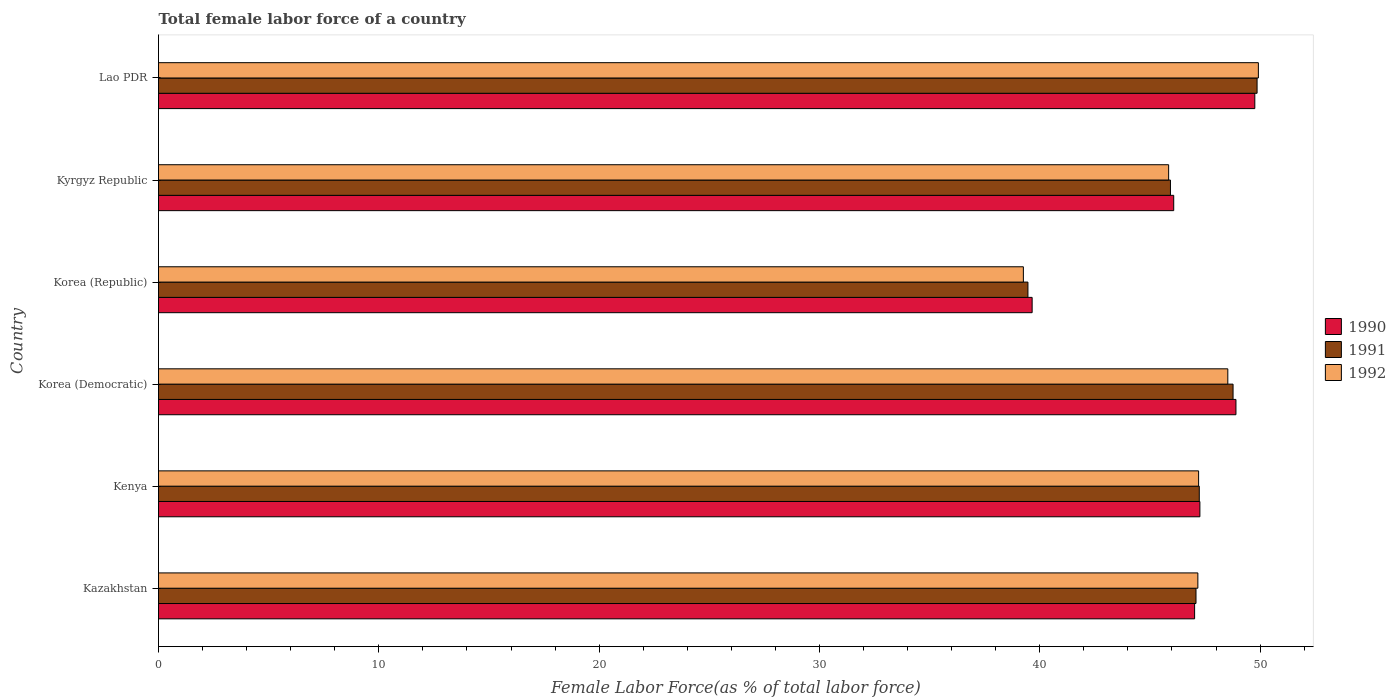How many different coloured bars are there?
Keep it short and to the point. 3. How many groups of bars are there?
Offer a very short reply. 6. How many bars are there on the 2nd tick from the top?
Offer a very short reply. 3. What is the label of the 6th group of bars from the top?
Make the answer very short. Kazakhstan. What is the percentage of female labor force in 1991 in Korea (Democratic)?
Your response must be concise. 48.77. Across all countries, what is the maximum percentage of female labor force in 1992?
Make the answer very short. 49.92. Across all countries, what is the minimum percentage of female labor force in 1991?
Offer a very short reply. 39.46. In which country was the percentage of female labor force in 1991 maximum?
Ensure brevity in your answer.  Lao PDR. What is the total percentage of female labor force in 1991 in the graph?
Provide a succinct answer. 278.37. What is the difference between the percentage of female labor force in 1990 in Kenya and that in Korea (Republic)?
Your answer should be compact. 7.61. What is the difference between the percentage of female labor force in 1992 in Korea (Democratic) and the percentage of female labor force in 1990 in Kazakhstan?
Ensure brevity in your answer.  1.51. What is the average percentage of female labor force in 1992 per country?
Make the answer very short. 46.33. What is the difference between the percentage of female labor force in 1991 and percentage of female labor force in 1990 in Korea (Republic)?
Keep it short and to the point. -0.19. In how many countries, is the percentage of female labor force in 1990 greater than 44 %?
Provide a succinct answer. 5. What is the ratio of the percentage of female labor force in 1992 in Korea (Democratic) to that in Kyrgyz Republic?
Your answer should be compact. 1.06. Is the difference between the percentage of female labor force in 1991 in Kyrgyz Republic and Lao PDR greater than the difference between the percentage of female labor force in 1990 in Kyrgyz Republic and Lao PDR?
Ensure brevity in your answer.  No. What is the difference between the highest and the second highest percentage of female labor force in 1991?
Make the answer very short. 1.09. What is the difference between the highest and the lowest percentage of female labor force in 1990?
Offer a very short reply. 10.11. Is the sum of the percentage of female labor force in 1992 in Kenya and Korea (Republic) greater than the maximum percentage of female labor force in 1991 across all countries?
Offer a terse response. Yes. Where does the legend appear in the graph?
Give a very brief answer. Center right. How many legend labels are there?
Ensure brevity in your answer.  3. What is the title of the graph?
Keep it short and to the point. Total female labor force of a country. What is the label or title of the X-axis?
Your answer should be compact. Female Labor Force(as % of total labor force). What is the label or title of the Y-axis?
Make the answer very short. Country. What is the Female Labor Force(as % of total labor force) of 1990 in Kazakhstan?
Provide a succinct answer. 47.03. What is the Female Labor Force(as % of total labor force) of 1991 in Kazakhstan?
Make the answer very short. 47.09. What is the Female Labor Force(as % of total labor force) in 1992 in Kazakhstan?
Your response must be concise. 47.18. What is the Female Labor Force(as % of total labor force) in 1990 in Kenya?
Offer a terse response. 47.27. What is the Female Labor Force(as % of total labor force) of 1991 in Kenya?
Offer a very short reply. 47.24. What is the Female Labor Force(as % of total labor force) of 1992 in Kenya?
Offer a very short reply. 47.21. What is the Female Labor Force(as % of total labor force) in 1990 in Korea (Democratic)?
Provide a succinct answer. 48.91. What is the Female Labor Force(as % of total labor force) of 1991 in Korea (Democratic)?
Offer a very short reply. 48.77. What is the Female Labor Force(as % of total labor force) in 1992 in Korea (Democratic)?
Your answer should be very brief. 48.54. What is the Female Labor Force(as % of total labor force) of 1990 in Korea (Republic)?
Provide a succinct answer. 39.65. What is the Female Labor Force(as % of total labor force) of 1991 in Korea (Republic)?
Offer a terse response. 39.46. What is the Female Labor Force(as % of total labor force) of 1992 in Korea (Republic)?
Provide a succinct answer. 39.26. What is the Female Labor Force(as % of total labor force) in 1990 in Kyrgyz Republic?
Provide a short and direct response. 46.08. What is the Female Labor Force(as % of total labor force) in 1991 in Kyrgyz Republic?
Offer a very short reply. 45.93. What is the Female Labor Force(as % of total labor force) in 1992 in Kyrgyz Republic?
Keep it short and to the point. 45.85. What is the Female Labor Force(as % of total labor force) in 1990 in Lao PDR?
Provide a succinct answer. 49.76. What is the Female Labor Force(as % of total labor force) in 1991 in Lao PDR?
Your response must be concise. 49.86. What is the Female Labor Force(as % of total labor force) in 1992 in Lao PDR?
Your answer should be very brief. 49.92. Across all countries, what is the maximum Female Labor Force(as % of total labor force) of 1990?
Provide a short and direct response. 49.76. Across all countries, what is the maximum Female Labor Force(as % of total labor force) in 1991?
Provide a succinct answer. 49.86. Across all countries, what is the maximum Female Labor Force(as % of total labor force) in 1992?
Ensure brevity in your answer.  49.92. Across all countries, what is the minimum Female Labor Force(as % of total labor force) of 1990?
Your answer should be very brief. 39.65. Across all countries, what is the minimum Female Labor Force(as % of total labor force) of 1991?
Your answer should be compact. 39.46. Across all countries, what is the minimum Female Labor Force(as % of total labor force) of 1992?
Give a very brief answer. 39.26. What is the total Female Labor Force(as % of total labor force) in 1990 in the graph?
Keep it short and to the point. 278.7. What is the total Female Labor Force(as % of total labor force) of 1991 in the graph?
Your answer should be very brief. 278.37. What is the total Female Labor Force(as % of total labor force) of 1992 in the graph?
Give a very brief answer. 277.95. What is the difference between the Female Labor Force(as % of total labor force) in 1990 in Kazakhstan and that in Kenya?
Your answer should be very brief. -0.24. What is the difference between the Female Labor Force(as % of total labor force) of 1991 in Kazakhstan and that in Kenya?
Make the answer very short. -0.15. What is the difference between the Female Labor Force(as % of total labor force) of 1992 in Kazakhstan and that in Kenya?
Offer a terse response. -0.03. What is the difference between the Female Labor Force(as % of total labor force) of 1990 in Kazakhstan and that in Korea (Democratic)?
Give a very brief answer. -1.88. What is the difference between the Female Labor Force(as % of total labor force) of 1991 in Kazakhstan and that in Korea (Democratic)?
Ensure brevity in your answer.  -1.68. What is the difference between the Female Labor Force(as % of total labor force) of 1992 in Kazakhstan and that in Korea (Democratic)?
Ensure brevity in your answer.  -1.36. What is the difference between the Female Labor Force(as % of total labor force) in 1990 in Kazakhstan and that in Korea (Republic)?
Give a very brief answer. 7.37. What is the difference between the Female Labor Force(as % of total labor force) in 1991 in Kazakhstan and that in Korea (Republic)?
Offer a terse response. 7.63. What is the difference between the Female Labor Force(as % of total labor force) of 1992 in Kazakhstan and that in Korea (Republic)?
Keep it short and to the point. 7.92. What is the difference between the Female Labor Force(as % of total labor force) in 1990 in Kazakhstan and that in Kyrgyz Republic?
Your response must be concise. 0.95. What is the difference between the Female Labor Force(as % of total labor force) in 1991 in Kazakhstan and that in Kyrgyz Republic?
Give a very brief answer. 1.16. What is the difference between the Female Labor Force(as % of total labor force) in 1992 in Kazakhstan and that in Kyrgyz Republic?
Your answer should be compact. 1.33. What is the difference between the Female Labor Force(as % of total labor force) in 1990 in Kazakhstan and that in Lao PDR?
Your response must be concise. -2.73. What is the difference between the Female Labor Force(as % of total labor force) of 1991 in Kazakhstan and that in Lao PDR?
Provide a succinct answer. -2.77. What is the difference between the Female Labor Force(as % of total labor force) in 1992 in Kazakhstan and that in Lao PDR?
Give a very brief answer. -2.75. What is the difference between the Female Labor Force(as % of total labor force) of 1990 in Kenya and that in Korea (Democratic)?
Provide a short and direct response. -1.64. What is the difference between the Female Labor Force(as % of total labor force) in 1991 in Kenya and that in Korea (Democratic)?
Make the answer very short. -1.53. What is the difference between the Female Labor Force(as % of total labor force) of 1992 in Kenya and that in Korea (Democratic)?
Provide a succinct answer. -1.33. What is the difference between the Female Labor Force(as % of total labor force) of 1990 in Kenya and that in Korea (Republic)?
Provide a succinct answer. 7.61. What is the difference between the Female Labor Force(as % of total labor force) in 1991 in Kenya and that in Korea (Republic)?
Keep it short and to the point. 7.78. What is the difference between the Female Labor Force(as % of total labor force) in 1992 in Kenya and that in Korea (Republic)?
Offer a terse response. 7.95. What is the difference between the Female Labor Force(as % of total labor force) of 1990 in Kenya and that in Kyrgyz Republic?
Offer a terse response. 1.19. What is the difference between the Female Labor Force(as % of total labor force) of 1991 in Kenya and that in Kyrgyz Republic?
Your answer should be compact. 1.31. What is the difference between the Female Labor Force(as % of total labor force) of 1992 in Kenya and that in Kyrgyz Republic?
Your answer should be very brief. 1.36. What is the difference between the Female Labor Force(as % of total labor force) of 1990 in Kenya and that in Lao PDR?
Provide a short and direct response. -2.49. What is the difference between the Female Labor Force(as % of total labor force) in 1991 in Kenya and that in Lao PDR?
Offer a very short reply. -2.62. What is the difference between the Female Labor Force(as % of total labor force) of 1992 in Kenya and that in Lao PDR?
Provide a succinct answer. -2.71. What is the difference between the Female Labor Force(as % of total labor force) in 1990 in Korea (Democratic) and that in Korea (Republic)?
Your answer should be compact. 9.25. What is the difference between the Female Labor Force(as % of total labor force) of 1991 in Korea (Democratic) and that in Korea (Republic)?
Provide a short and direct response. 9.31. What is the difference between the Female Labor Force(as % of total labor force) of 1992 in Korea (Democratic) and that in Korea (Republic)?
Keep it short and to the point. 9.28. What is the difference between the Female Labor Force(as % of total labor force) of 1990 in Korea (Democratic) and that in Kyrgyz Republic?
Provide a short and direct response. 2.82. What is the difference between the Female Labor Force(as % of total labor force) of 1991 in Korea (Democratic) and that in Kyrgyz Republic?
Offer a terse response. 2.84. What is the difference between the Female Labor Force(as % of total labor force) of 1992 in Korea (Democratic) and that in Kyrgyz Republic?
Your response must be concise. 2.69. What is the difference between the Female Labor Force(as % of total labor force) in 1990 in Korea (Democratic) and that in Lao PDR?
Provide a succinct answer. -0.86. What is the difference between the Female Labor Force(as % of total labor force) in 1991 in Korea (Democratic) and that in Lao PDR?
Your response must be concise. -1.09. What is the difference between the Female Labor Force(as % of total labor force) in 1992 in Korea (Democratic) and that in Lao PDR?
Provide a succinct answer. -1.39. What is the difference between the Female Labor Force(as % of total labor force) of 1990 in Korea (Republic) and that in Kyrgyz Republic?
Provide a short and direct response. -6.43. What is the difference between the Female Labor Force(as % of total labor force) in 1991 in Korea (Republic) and that in Kyrgyz Republic?
Keep it short and to the point. -6.47. What is the difference between the Female Labor Force(as % of total labor force) of 1992 in Korea (Republic) and that in Kyrgyz Republic?
Your answer should be compact. -6.59. What is the difference between the Female Labor Force(as % of total labor force) in 1990 in Korea (Republic) and that in Lao PDR?
Give a very brief answer. -10.11. What is the difference between the Female Labor Force(as % of total labor force) in 1991 in Korea (Republic) and that in Lao PDR?
Your response must be concise. -10.4. What is the difference between the Female Labor Force(as % of total labor force) in 1992 in Korea (Republic) and that in Lao PDR?
Give a very brief answer. -10.67. What is the difference between the Female Labor Force(as % of total labor force) in 1990 in Kyrgyz Republic and that in Lao PDR?
Give a very brief answer. -3.68. What is the difference between the Female Labor Force(as % of total labor force) of 1991 in Kyrgyz Republic and that in Lao PDR?
Give a very brief answer. -3.93. What is the difference between the Female Labor Force(as % of total labor force) in 1992 in Kyrgyz Republic and that in Lao PDR?
Offer a terse response. -4.07. What is the difference between the Female Labor Force(as % of total labor force) of 1990 in Kazakhstan and the Female Labor Force(as % of total labor force) of 1991 in Kenya?
Ensure brevity in your answer.  -0.21. What is the difference between the Female Labor Force(as % of total labor force) of 1990 in Kazakhstan and the Female Labor Force(as % of total labor force) of 1992 in Kenya?
Offer a very short reply. -0.18. What is the difference between the Female Labor Force(as % of total labor force) of 1991 in Kazakhstan and the Female Labor Force(as % of total labor force) of 1992 in Kenya?
Your response must be concise. -0.12. What is the difference between the Female Labor Force(as % of total labor force) in 1990 in Kazakhstan and the Female Labor Force(as % of total labor force) in 1991 in Korea (Democratic)?
Your answer should be very brief. -1.74. What is the difference between the Female Labor Force(as % of total labor force) of 1990 in Kazakhstan and the Female Labor Force(as % of total labor force) of 1992 in Korea (Democratic)?
Offer a terse response. -1.51. What is the difference between the Female Labor Force(as % of total labor force) in 1991 in Kazakhstan and the Female Labor Force(as % of total labor force) in 1992 in Korea (Democratic)?
Give a very brief answer. -1.44. What is the difference between the Female Labor Force(as % of total labor force) of 1990 in Kazakhstan and the Female Labor Force(as % of total labor force) of 1991 in Korea (Republic)?
Make the answer very short. 7.57. What is the difference between the Female Labor Force(as % of total labor force) in 1990 in Kazakhstan and the Female Labor Force(as % of total labor force) in 1992 in Korea (Republic)?
Make the answer very short. 7.77. What is the difference between the Female Labor Force(as % of total labor force) in 1991 in Kazakhstan and the Female Labor Force(as % of total labor force) in 1992 in Korea (Republic)?
Make the answer very short. 7.84. What is the difference between the Female Labor Force(as % of total labor force) of 1990 in Kazakhstan and the Female Labor Force(as % of total labor force) of 1991 in Kyrgyz Republic?
Your answer should be compact. 1.1. What is the difference between the Female Labor Force(as % of total labor force) of 1990 in Kazakhstan and the Female Labor Force(as % of total labor force) of 1992 in Kyrgyz Republic?
Keep it short and to the point. 1.18. What is the difference between the Female Labor Force(as % of total labor force) in 1991 in Kazakhstan and the Female Labor Force(as % of total labor force) in 1992 in Kyrgyz Republic?
Offer a terse response. 1.24. What is the difference between the Female Labor Force(as % of total labor force) in 1990 in Kazakhstan and the Female Labor Force(as % of total labor force) in 1991 in Lao PDR?
Your answer should be compact. -2.84. What is the difference between the Female Labor Force(as % of total labor force) of 1990 in Kazakhstan and the Female Labor Force(as % of total labor force) of 1992 in Lao PDR?
Ensure brevity in your answer.  -2.89. What is the difference between the Female Labor Force(as % of total labor force) of 1991 in Kazakhstan and the Female Labor Force(as % of total labor force) of 1992 in Lao PDR?
Your response must be concise. -2.83. What is the difference between the Female Labor Force(as % of total labor force) of 1990 in Kenya and the Female Labor Force(as % of total labor force) of 1991 in Korea (Democratic)?
Offer a terse response. -1.51. What is the difference between the Female Labor Force(as % of total labor force) in 1990 in Kenya and the Female Labor Force(as % of total labor force) in 1992 in Korea (Democratic)?
Offer a terse response. -1.27. What is the difference between the Female Labor Force(as % of total labor force) of 1991 in Kenya and the Female Labor Force(as % of total labor force) of 1992 in Korea (Democratic)?
Keep it short and to the point. -1.29. What is the difference between the Female Labor Force(as % of total labor force) in 1990 in Kenya and the Female Labor Force(as % of total labor force) in 1991 in Korea (Republic)?
Ensure brevity in your answer.  7.8. What is the difference between the Female Labor Force(as % of total labor force) of 1990 in Kenya and the Female Labor Force(as % of total labor force) of 1992 in Korea (Republic)?
Your answer should be compact. 8.01. What is the difference between the Female Labor Force(as % of total labor force) in 1991 in Kenya and the Female Labor Force(as % of total labor force) in 1992 in Korea (Republic)?
Provide a succinct answer. 7.98. What is the difference between the Female Labor Force(as % of total labor force) in 1990 in Kenya and the Female Labor Force(as % of total labor force) in 1991 in Kyrgyz Republic?
Your answer should be very brief. 1.34. What is the difference between the Female Labor Force(as % of total labor force) of 1990 in Kenya and the Female Labor Force(as % of total labor force) of 1992 in Kyrgyz Republic?
Ensure brevity in your answer.  1.42. What is the difference between the Female Labor Force(as % of total labor force) in 1991 in Kenya and the Female Labor Force(as % of total labor force) in 1992 in Kyrgyz Republic?
Your answer should be very brief. 1.39. What is the difference between the Female Labor Force(as % of total labor force) of 1990 in Kenya and the Female Labor Force(as % of total labor force) of 1991 in Lao PDR?
Keep it short and to the point. -2.6. What is the difference between the Female Labor Force(as % of total labor force) in 1990 in Kenya and the Female Labor Force(as % of total labor force) in 1992 in Lao PDR?
Your response must be concise. -2.65. What is the difference between the Female Labor Force(as % of total labor force) of 1991 in Kenya and the Female Labor Force(as % of total labor force) of 1992 in Lao PDR?
Your answer should be compact. -2.68. What is the difference between the Female Labor Force(as % of total labor force) in 1990 in Korea (Democratic) and the Female Labor Force(as % of total labor force) in 1991 in Korea (Republic)?
Your answer should be very brief. 9.44. What is the difference between the Female Labor Force(as % of total labor force) of 1990 in Korea (Democratic) and the Female Labor Force(as % of total labor force) of 1992 in Korea (Republic)?
Your response must be concise. 9.65. What is the difference between the Female Labor Force(as % of total labor force) in 1991 in Korea (Democratic) and the Female Labor Force(as % of total labor force) in 1992 in Korea (Republic)?
Give a very brief answer. 9.52. What is the difference between the Female Labor Force(as % of total labor force) in 1990 in Korea (Democratic) and the Female Labor Force(as % of total labor force) in 1991 in Kyrgyz Republic?
Your response must be concise. 2.97. What is the difference between the Female Labor Force(as % of total labor force) in 1990 in Korea (Democratic) and the Female Labor Force(as % of total labor force) in 1992 in Kyrgyz Republic?
Your answer should be very brief. 3.06. What is the difference between the Female Labor Force(as % of total labor force) in 1991 in Korea (Democratic) and the Female Labor Force(as % of total labor force) in 1992 in Kyrgyz Republic?
Offer a terse response. 2.92. What is the difference between the Female Labor Force(as % of total labor force) of 1990 in Korea (Democratic) and the Female Labor Force(as % of total labor force) of 1991 in Lao PDR?
Ensure brevity in your answer.  -0.96. What is the difference between the Female Labor Force(as % of total labor force) in 1990 in Korea (Democratic) and the Female Labor Force(as % of total labor force) in 1992 in Lao PDR?
Give a very brief answer. -1.02. What is the difference between the Female Labor Force(as % of total labor force) in 1991 in Korea (Democratic) and the Female Labor Force(as % of total labor force) in 1992 in Lao PDR?
Provide a succinct answer. -1.15. What is the difference between the Female Labor Force(as % of total labor force) of 1990 in Korea (Republic) and the Female Labor Force(as % of total labor force) of 1991 in Kyrgyz Republic?
Ensure brevity in your answer.  -6.28. What is the difference between the Female Labor Force(as % of total labor force) of 1990 in Korea (Republic) and the Female Labor Force(as % of total labor force) of 1992 in Kyrgyz Republic?
Give a very brief answer. -6.2. What is the difference between the Female Labor Force(as % of total labor force) of 1991 in Korea (Republic) and the Female Labor Force(as % of total labor force) of 1992 in Kyrgyz Republic?
Offer a terse response. -6.39. What is the difference between the Female Labor Force(as % of total labor force) in 1990 in Korea (Republic) and the Female Labor Force(as % of total labor force) in 1991 in Lao PDR?
Provide a succinct answer. -10.21. What is the difference between the Female Labor Force(as % of total labor force) of 1990 in Korea (Republic) and the Female Labor Force(as % of total labor force) of 1992 in Lao PDR?
Your answer should be very brief. -10.27. What is the difference between the Female Labor Force(as % of total labor force) of 1991 in Korea (Republic) and the Female Labor Force(as % of total labor force) of 1992 in Lao PDR?
Your answer should be very brief. -10.46. What is the difference between the Female Labor Force(as % of total labor force) of 1990 in Kyrgyz Republic and the Female Labor Force(as % of total labor force) of 1991 in Lao PDR?
Keep it short and to the point. -3.78. What is the difference between the Female Labor Force(as % of total labor force) of 1990 in Kyrgyz Republic and the Female Labor Force(as % of total labor force) of 1992 in Lao PDR?
Provide a succinct answer. -3.84. What is the difference between the Female Labor Force(as % of total labor force) of 1991 in Kyrgyz Republic and the Female Labor Force(as % of total labor force) of 1992 in Lao PDR?
Keep it short and to the point. -3.99. What is the average Female Labor Force(as % of total labor force) in 1990 per country?
Make the answer very short. 46.45. What is the average Female Labor Force(as % of total labor force) in 1991 per country?
Your answer should be very brief. 46.39. What is the average Female Labor Force(as % of total labor force) in 1992 per country?
Your answer should be compact. 46.33. What is the difference between the Female Labor Force(as % of total labor force) of 1990 and Female Labor Force(as % of total labor force) of 1991 in Kazakhstan?
Your response must be concise. -0.06. What is the difference between the Female Labor Force(as % of total labor force) of 1990 and Female Labor Force(as % of total labor force) of 1992 in Kazakhstan?
Ensure brevity in your answer.  -0.15. What is the difference between the Female Labor Force(as % of total labor force) of 1991 and Female Labor Force(as % of total labor force) of 1992 in Kazakhstan?
Make the answer very short. -0.08. What is the difference between the Female Labor Force(as % of total labor force) of 1990 and Female Labor Force(as % of total labor force) of 1991 in Kenya?
Offer a very short reply. 0.03. What is the difference between the Female Labor Force(as % of total labor force) of 1990 and Female Labor Force(as % of total labor force) of 1992 in Kenya?
Make the answer very short. 0.06. What is the difference between the Female Labor Force(as % of total labor force) of 1991 and Female Labor Force(as % of total labor force) of 1992 in Kenya?
Your answer should be very brief. 0.03. What is the difference between the Female Labor Force(as % of total labor force) of 1990 and Female Labor Force(as % of total labor force) of 1991 in Korea (Democratic)?
Provide a short and direct response. 0.13. What is the difference between the Female Labor Force(as % of total labor force) in 1990 and Female Labor Force(as % of total labor force) in 1992 in Korea (Democratic)?
Provide a short and direct response. 0.37. What is the difference between the Female Labor Force(as % of total labor force) in 1991 and Female Labor Force(as % of total labor force) in 1992 in Korea (Democratic)?
Your response must be concise. 0.24. What is the difference between the Female Labor Force(as % of total labor force) of 1990 and Female Labor Force(as % of total labor force) of 1991 in Korea (Republic)?
Your response must be concise. 0.19. What is the difference between the Female Labor Force(as % of total labor force) in 1990 and Female Labor Force(as % of total labor force) in 1992 in Korea (Republic)?
Keep it short and to the point. 0.4. What is the difference between the Female Labor Force(as % of total labor force) in 1991 and Female Labor Force(as % of total labor force) in 1992 in Korea (Republic)?
Offer a very short reply. 0.21. What is the difference between the Female Labor Force(as % of total labor force) in 1990 and Female Labor Force(as % of total labor force) in 1991 in Kyrgyz Republic?
Offer a very short reply. 0.15. What is the difference between the Female Labor Force(as % of total labor force) of 1990 and Female Labor Force(as % of total labor force) of 1992 in Kyrgyz Republic?
Keep it short and to the point. 0.23. What is the difference between the Female Labor Force(as % of total labor force) in 1991 and Female Labor Force(as % of total labor force) in 1992 in Kyrgyz Republic?
Give a very brief answer. 0.08. What is the difference between the Female Labor Force(as % of total labor force) of 1990 and Female Labor Force(as % of total labor force) of 1991 in Lao PDR?
Offer a terse response. -0.1. What is the difference between the Female Labor Force(as % of total labor force) of 1990 and Female Labor Force(as % of total labor force) of 1992 in Lao PDR?
Give a very brief answer. -0.16. What is the difference between the Female Labor Force(as % of total labor force) of 1991 and Female Labor Force(as % of total labor force) of 1992 in Lao PDR?
Your response must be concise. -0.06. What is the ratio of the Female Labor Force(as % of total labor force) in 1990 in Kazakhstan to that in Korea (Democratic)?
Keep it short and to the point. 0.96. What is the ratio of the Female Labor Force(as % of total labor force) of 1991 in Kazakhstan to that in Korea (Democratic)?
Offer a terse response. 0.97. What is the ratio of the Female Labor Force(as % of total labor force) of 1992 in Kazakhstan to that in Korea (Democratic)?
Ensure brevity in your answer.  0.97. What is the ratio of the Female Labor Force(as % of total labor force) in 1990 in Kazakhstan to that in Korea (Republic)?
Offer a terse response. 1.19. What is the ratio of the Female Labor Force(as % of total labor force) in 1991 in Kazakhstan to that in Korea (Republic)?
Provide a short and direct response. 1.19. What is the ratio of the Female Labor Force(as % of total labor force) in 1992 in Kazakhstan to that in Korea (Republic)?
Give a very brief answer. 1.2. What is the ratio of the Female Labor Force(as % of total labor force) in 1990 in Kazakhstan to that in Kyrgyz Republic?
Provide a short and direct response. 1.02. What is the ratio of the Female Labor Force(as % of total labor force) of 1991 in Kazakhstan to that in Kyrgyz Republic?
Your answer should be very brief. 1.03. What is the ratio of the Female Labor Force(as % of total labor force) in 1992 in Kazakhstan to that in Kyrgyz Republic?
Offer a very short reply. 1.03. What is the ratio of the Female Labor Force(as % of total labor force) of 1990 in Kazakhstan to that in Lao PDR?
Your response must be concise. 0.95. What is the ratio of the Female Labor Force(as % of total labor force) in 1992 in Kazakhstan to that in Lao PDR?
Provide a succinct answer. 0.94. What is the ratio of the Female Labor Force(as % of total labor force) of 1990 in Kenya to that in Korea (Democratic)?
Offer a terse response. 0.97. What is the ratio of the Female Labor Force(as % of total labor force) of 1991 in Kenya to that in Korea (Democratic)?
Provide a succinct answer. 0.97. What is the ratio of the Female Labor Force(as % of total labor force) of 1992 in Kenya to that in Korea (Democratic)?
Your answer should be very brief. 0.97. What is the ratio of the Female Labor Force(as % of total labor force) in 1990 in Kenya to that in Korea (Republic)?
Make the answer very short. 1.19. What is the ratio of the Female Labor Force(as % of total labor force) in 1991 in Kenya to that in Korea (Republic)?
Provide a short and direct response. 1.2. What is the ratio of the Female Labor Force(as % of total labor force) in 1992 in Kenya to that in Korea (Republic)?
Keep it short and to the point. 1.2. What is the ratio of the Female Labor Force(as % of total labor force) of 1990 in Kenya to that in Kyrgyz Republic?
Keep it short and to the point. 1.03. What is the ratio of the Female Labor Force(as % of total labor force) of 1991 in Kenya to that in Kyrgyz Republic?
Give a very brief answer. 1.03. What is the ratio of the Female Labor Force(as % of total labor force) in 1992 in Kenya to that in Kyrgyz Republic?
Your answer should be very brief. 1.03. What is the ratio of the Female Labor Force(as % of total labor force) in 1990 in Kenya to that in Lao PDR?
Make the answer very short. 0.95. What is the ratio of the Female Labor Force(as % of total labor force) in 1991 in Kenya to that in Lao PDR?
Provide a short and direct response. 0.95. What is the ratio of the Female Labor Force(as % of total labor force) in 1992 in Kenya to that in Lao PDR?
Keep it short and to the point. 0.95. What is the ratio of the Female Labor Force(as % of total labor force) of 1990 in Korea (Democratic) to that in Korea (Republic)?
Keep it short and to the point. 1.23. What is the ratio of the Female Labor Force(as % of total labor force) of 1991 in Korea (Democratic) to that in Korea (Republic)?
Your response must be concise. 1.24. What is the ratio of the Female Labor Force(as % of total labor force) in 1992 in Korea (Democratic) to that in Korea (Republic)?
Make the answer very short. 1.24. What is the ratio of the Female Labor Force(as % of total labor force) in 1990 in Korea (Democratic) to that in Kyrgyz Republic?
Offer a terse response. 1.06. What is the ratio of the Female Labor Force(as % of total labor force) of 1991 in Korea (Democratic) to that in Kyrgyz Republic?
Provide a succinct answer. 1.06. What is the ratio of the Female Labor Force(as % of total labor force) in 1992 in Korea (Democratic) to that in Kyrgyz Republic?
Your response must be concise. 1.06. What is the ratio of the Female Labor Force(as % of total labor force) of 1990 in Korea (Democratic) to that in Lao PDR?
Give a very brief answer. 0.98. What is the ratio of the Female Labor Force(as % of total labor force) of 1991 in Korea (Democratic) to that in Lao PDR?
Provide a succinct answer. 0.98. What is the ratio of the Female Labor Force(as % of total labor force) in 1992 in Korea (Democratic) to that in Lao PDR?
Offer a terse response. 0.97. What is the ratio of the Female Labor Force(as % of total labor force) of 1990 in Korea (Republic) to that in Kyrgyz Republic?
Your answer should be compact. 0.86. What is the ratio of the Female Labor Force(as % of total labor force) of 1991 in Korea (Republic) to that in Kyrgyz Republic?
Your answer should be very brief. 0.86. What is the ratio of the Female Labor Force(as % of total labor force) in 1992 in Korea (Republic) to that in Kyrgyz Republic?
Offer a very short reply. 0.86. What is the ratio of the Female Labor Force(as % of total labor force) in 1990 in Korea (Republic) to that in Lao PDR?
Your answer should be compact. 0.8. What is the ratio of the Female Labor Force(as % of total labor force) in 1991 in Korea (Republic) to that in Lao PDR?
Make the answer very short. 0.79. What is the ratio of the Female Labor Force(as % of total labor force) in 1992 in Korea (Republic) to that in Lao PDR?
Make the answer very short. 0.79. What is the ratio of the Female Labor Force(as % of total labor force) in 1990 in Kyrgyz Republic to that in Lao PDR?
Keep it short and to the point. 0.93. What is the ratio of the Female Labor Force(as % of total labor force) in 1991 in Kyrgyz Republic to that in Lao PDR?
Your answer should be compact. 0.92. What is the ratio of the Female Labor Force(as % of total labor force) of 1992 in Kyrgyz Republic to that in Lao PDR?
Your response must be concise. 0.92. What is the difference between the highest and the second highest Female Labor Force(as % of total labor force) of 1990?
Your answer should be very brief. 0.86. What is the difference between the highest and the second highest Female Labor Force(as % of total labor force) in 1991?
Offer a very short reply. 1.09. What is the difference between the highest and the second highest Female Labor Force(as % of total labor force) in 1992?
Provide a short and direct response. 1.39. What is the difference between the highest and the lowest Female Labor Force(as % of total labor force) in 1990?
Keep it short and to the point. 10.11. What is the difference between the highest and the lowest Female Labor Force(as % of total labor force) in 1991?
Provide a short and direct response. 10.4. What is the difference between the highest and the lowest Female Labor Force(as % of total labor force) of 1992?
Your answer should be compact. 10.67. 